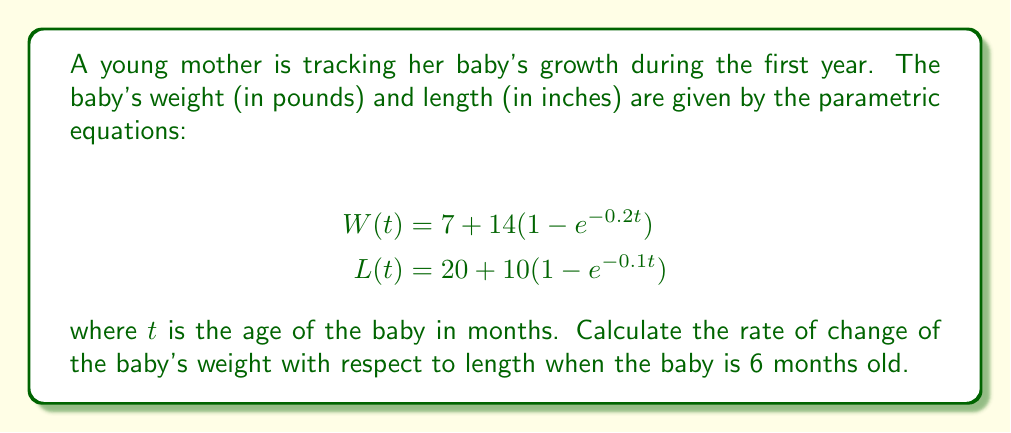Solve this math problem. To solve this problem, we need to follow these steps:

1) First, we need to find $\frac{dW}{dt}$ and $\frac{dL}{dt}$ at $t = 6$.

2) Then, we'll use the chain rule to find $\frac{dW}{dL}$:

   $$\frac{dW}{dL} = \frac{dW/dt}{dL/dt}$$

3) Let's start with $\frac{dW}{dt}$:
   
   $$\frac{dW}{dt} = 14(0.2e^{-0.2t})$$

   At $t = 6$:
   $$\frac{dW}{dt}|_{t=6} = 14(0.2e^{-0.2(6)}) \approx 1.26$$

4) Now for $\frac{dL}{dt}$:
   
   $$\frac{dL}{dt} = 10(0.1e^{-0.1t})$$

   At $t = 6$:
   $$\frac{dL}{dt}|_{t=6} = 10(0.1e^{-0.1(6)}) \approx 0.55$$

5) Now we can calculate $\frac{dW}{dL}$ at $t = 6$:

   $$\frac{dW}{dL}|_{t=6} = \frac{1.26}{0.55} \approx 2.29$$

This means that when the baby is 6 months old, for each inch the baby grows in length, they gain approximately 2.29 pounds in weight.
Answer: The rate of change of the baby's weight with respect to length at 6 months is approximately 2.29 pounds per inch. 